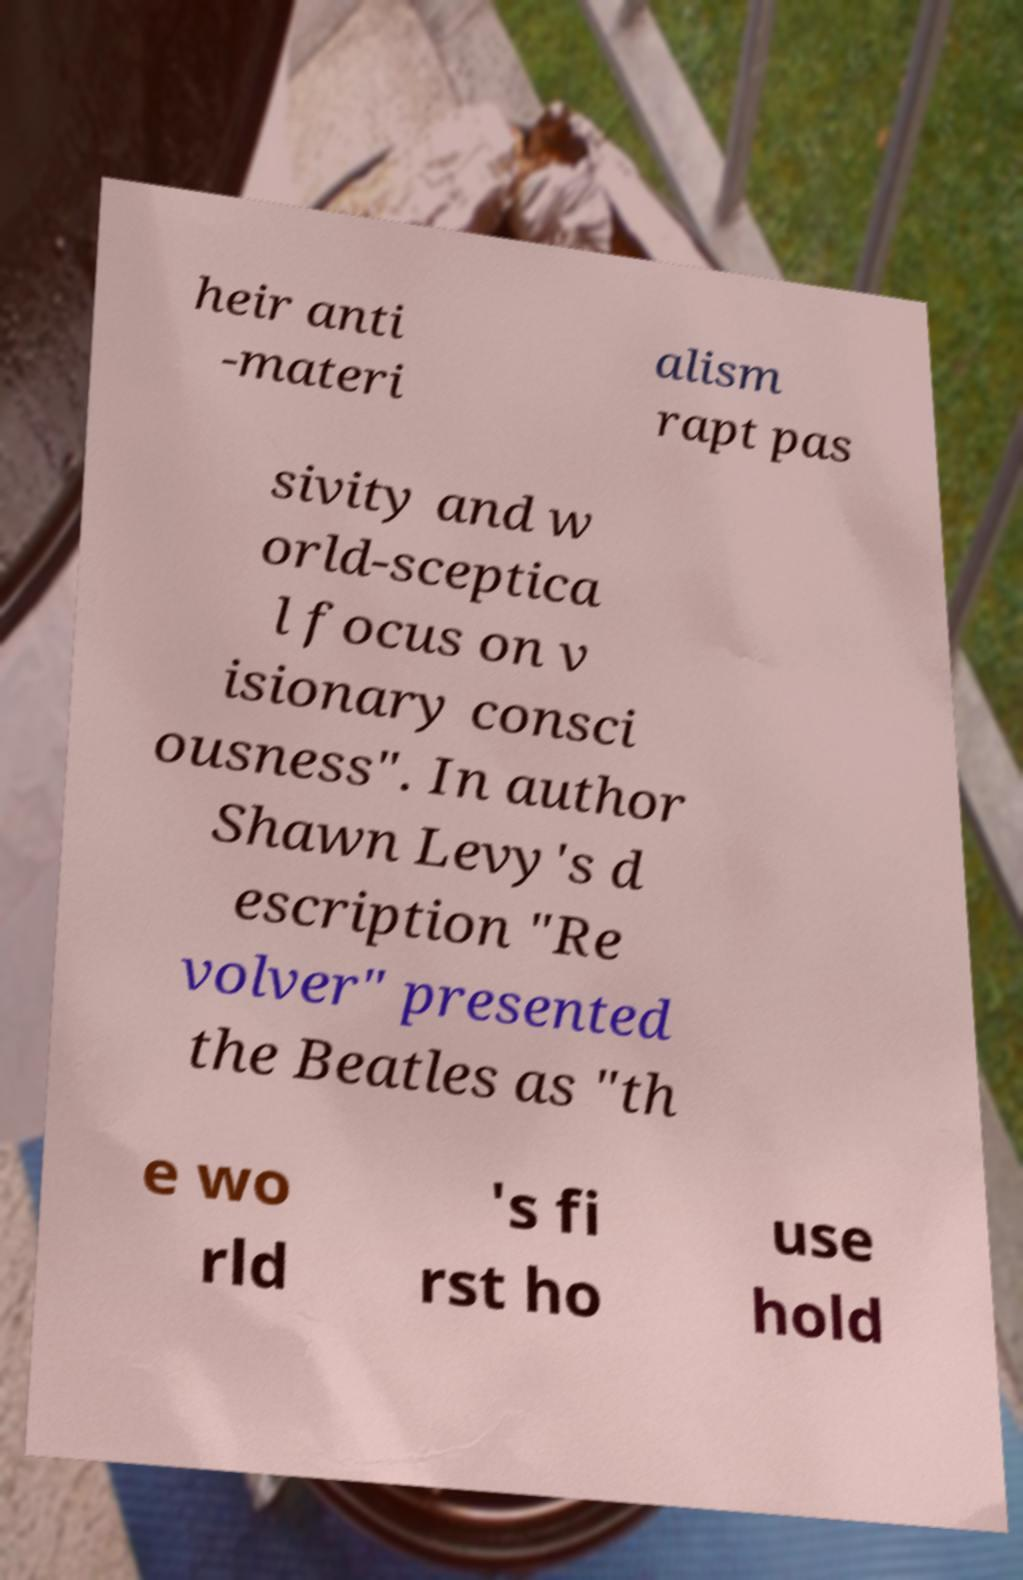Could you extract and type out the text from this image? heir anti -materi alism rapt pas sivity and w orld-sceptica l focus on v isionary consci ousness". In author Shawn Levy's d escription "Re volver" presented the Beatles as "th e wo rld 's fi rst ho use hold 